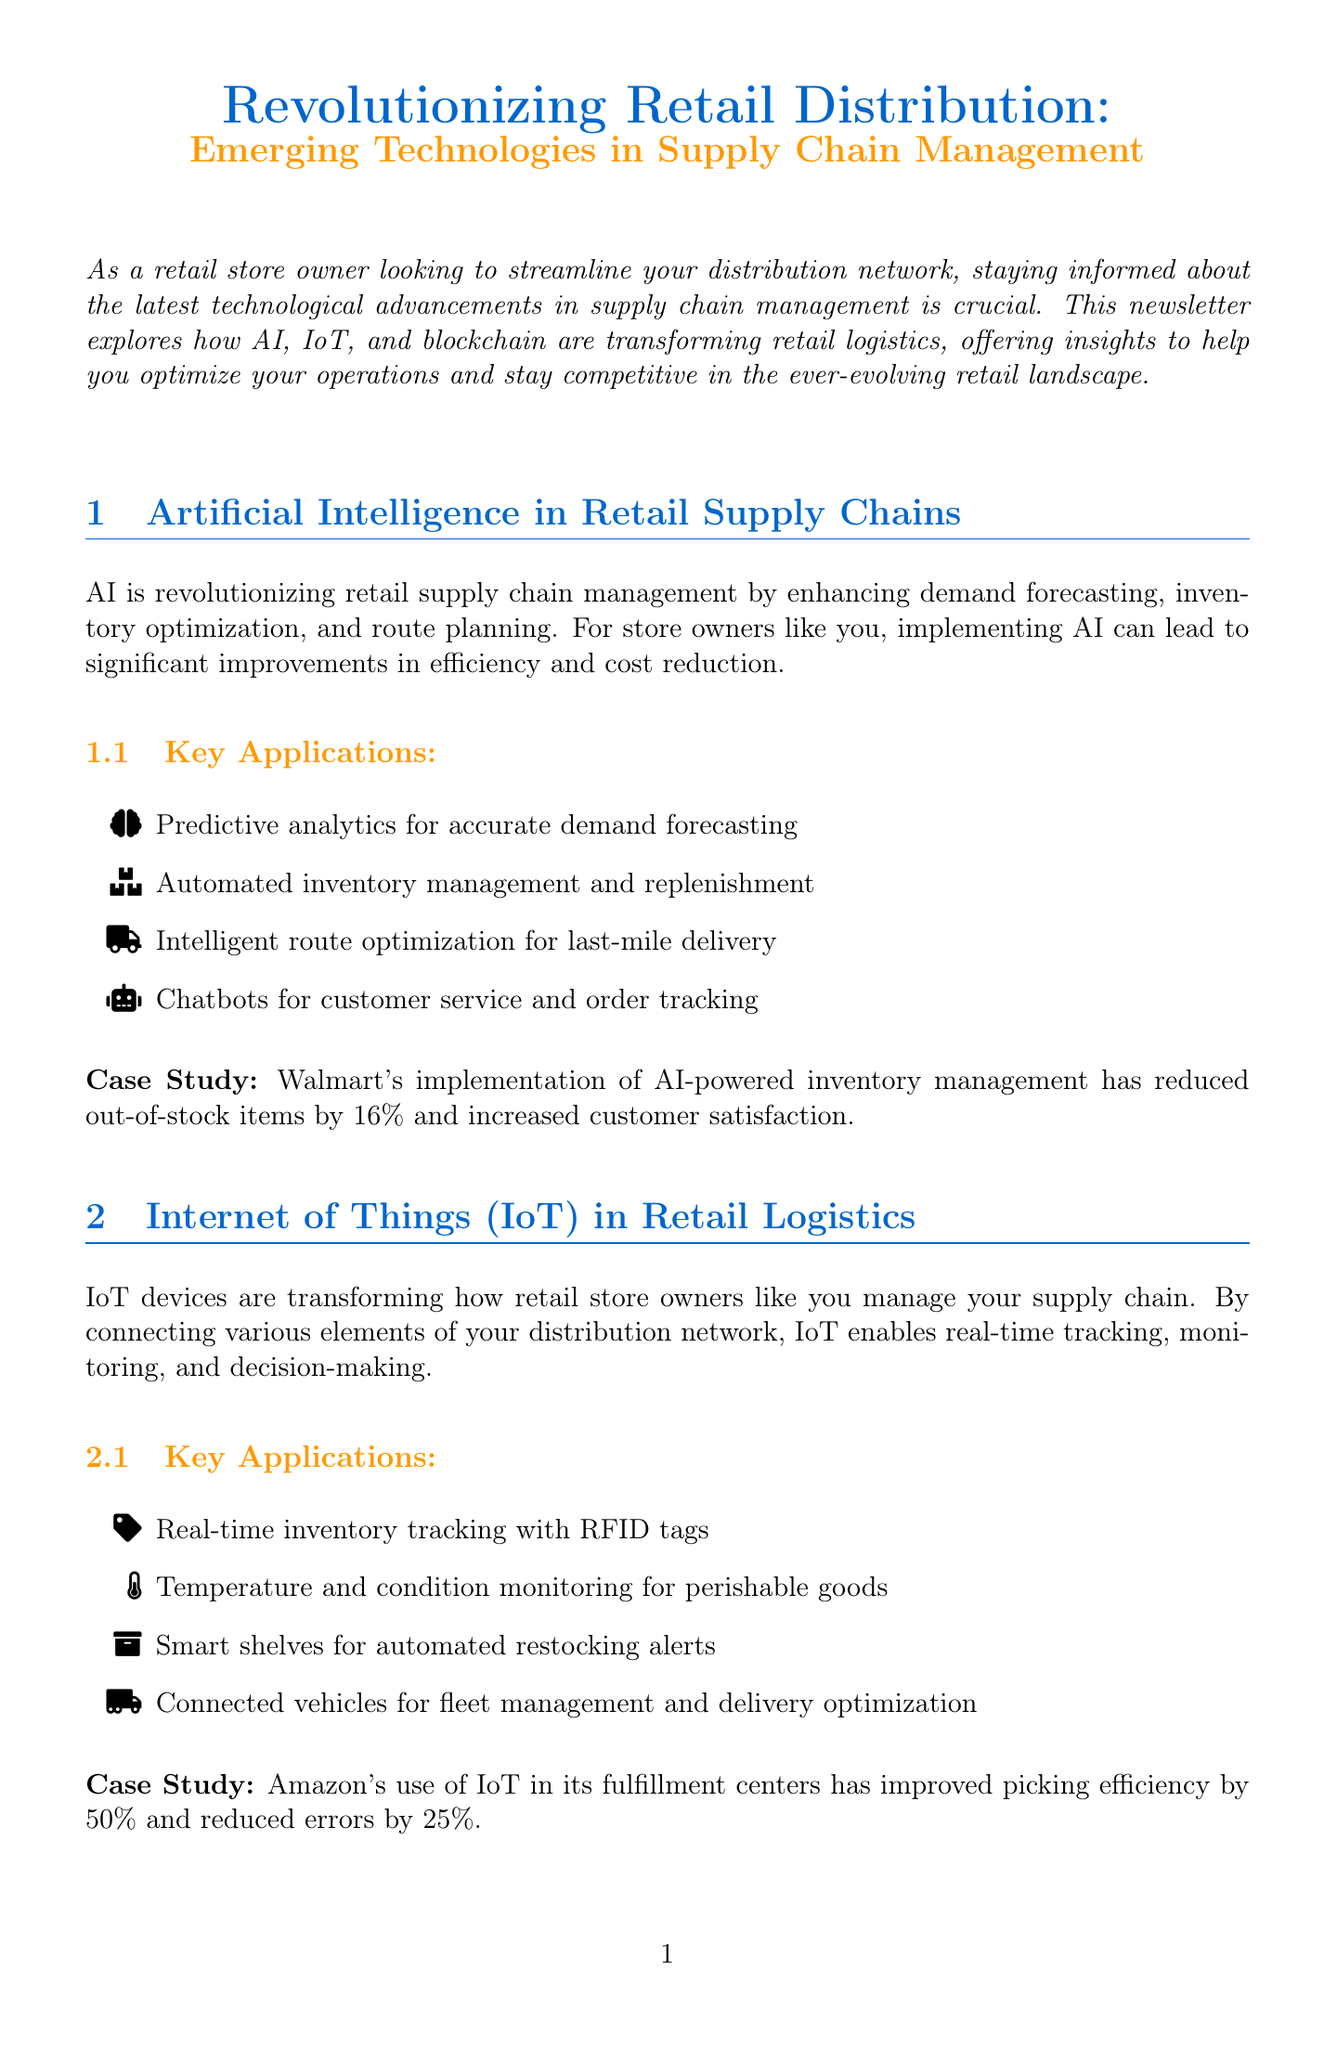What is the newsletter title? The title of the newsletter is usually prominently displayed at the top of the document, which is "Revolutionizing Retail Distribution: Emerging Technologies in Supply Chain Management."
Answer: Revolutionizing Retail Distribution: Emerging Technologies in Supply Chain Management What company is highlighted in the AI case study? The case study section provides specific examples, with Walmart mentioned for its AI implementation.
Answer: Walmart What percentage improvement in picking efficiency was achieved by Amazon using IoT? The document states that Amazon's use of IoT improved picking efficiency by a specific percentage, which is 50%.
Answer: 50% What are the four key applications of blockchain mentioned? The section on blockchain lists four key applications of the technology relevant to retail supply chains.
Answer: End-to-end product traceability, Smart contracts, Secure payments, Authenticity verification How much did Carrefour increase sales of tracked products? The document includes a case study showing that Carrefour saw a quantifiable increase in sales due to its blockchain implementation.
Answer: 10% What technology is primarily focused on demand forecasting? The infographic section highlights AI applications, specifically mentioning predictive analytics for demand forecasting.
Answer: AI Which technology helps with real-time inventory tracking? The section on IoT describes real-time inventory tracking as one of its key functions, using RFID tags.
Answer: IoT What is the conclusion's main suggestion for store owners? The conclusion summarizes the benefits and suggests to retail store owners to begin implementing these technologies gradually.
Answer: Embrace emerging technologies What is the call to action in the newsletter? The final part of the document typically encourages readers to reach out for assistance, providing a specific action to take.
Answer: Contact our team of experts 